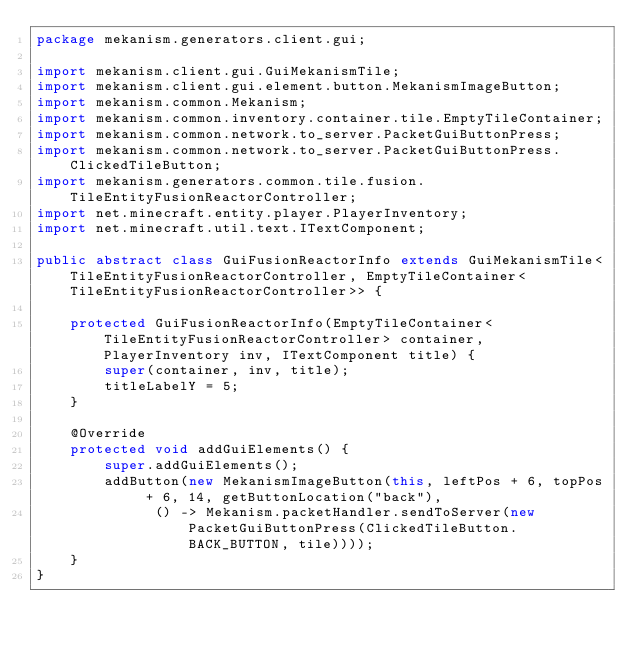Convert code to text. <code><loc_0><loc_0><loc_500><loc_500><_Java_>package mekanism.generators.client.gui;

import mekanism.client.gui.GuiMekanismTile;
import mekanism.client.gui.element.button.MekanismImageButton;
import mekanism.common.Mekanism;
import mekanism.common.inventory.container.tile.EmptyTileContainer;
import mekanism.common.network.to_server.PacketGuiButtonPress;
import mekanism.common.network.to_server.PacketGuiButtonPress.ClickedTileButton;
import mekanism.generators.common.tile.fusion.TileEntityFusionReactorController;
import net.minecraft.entity.player.PlayerInventory;
import net.minecraft.util.text.ITextComponent;

public abstract class GuiFusionReactorInfo extends GuiMekanismTile<TileEntityFusionReactorController, EmptyTileContainer<TileEntityFusionReactorController>> {

    protected GuiFusionReactorInfo(EmptyTileContainer<TileEntityFusionReactorController> container, PlayerInventory inv, ITextComponent title) {
        super(container, inv, title);
        titleLabelY = 5;
    }

    @Override
    protected void addGuiElements() {
        super.addGuiElements();
        addButton(new MekanismImageButton(this, leftPos + 6, topPos + 6, 14, getButtonLocation("back"),
              () -> Mekanism.packetHandler.sendToServer(new PacketGuiButtonPress(ClickedTileButton.BACK_BUTTON, tile))));
    }
}</code> 